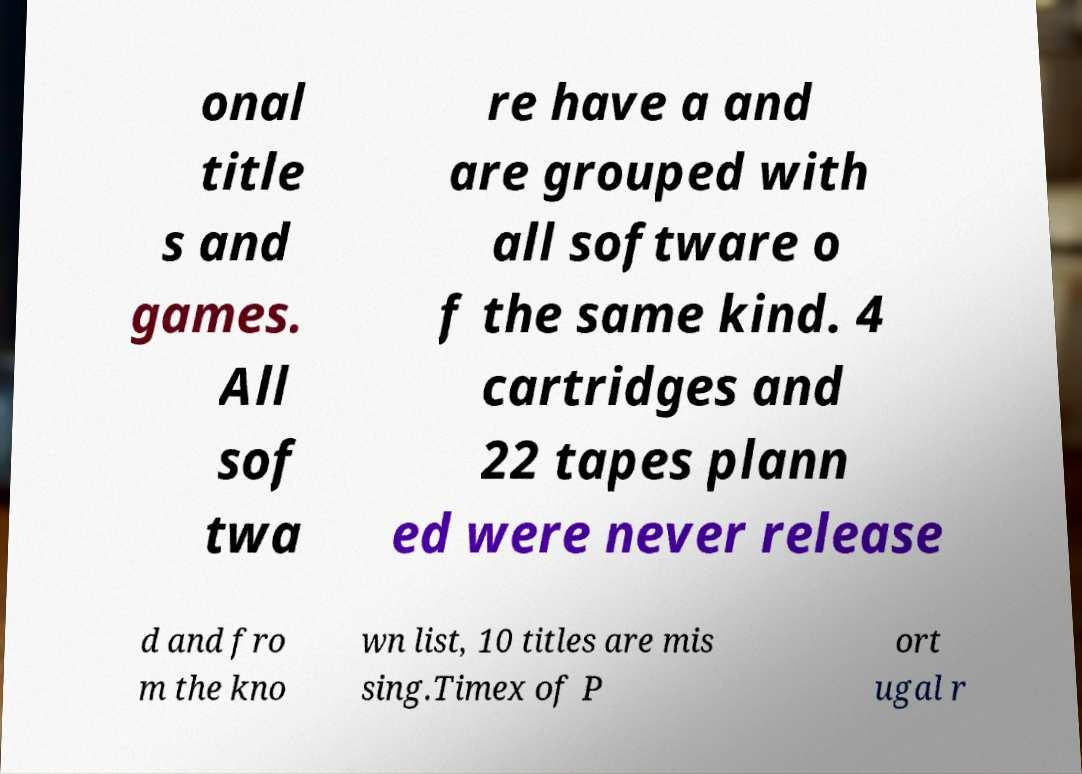What messages or text are displayed in this image? I need them in a readable, typed format. onal title s and games. All sof twa re have a and are grouped with all software o f the same kind. 4 cartridges and 22 tapes plann ed were never release d and fro m the kno wn list, 10 titles are mis sing.Timex of P ort ugal r 